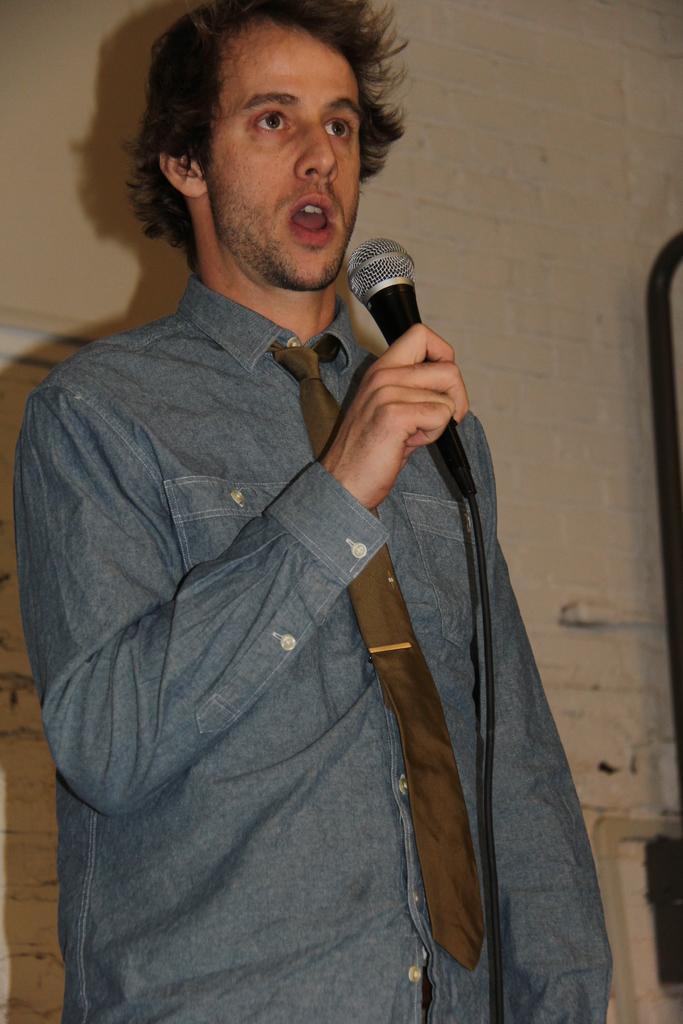Can you describe this image briefly? Here we can see a man speaking something in the microphone present in his hand, he is wearing a tie 